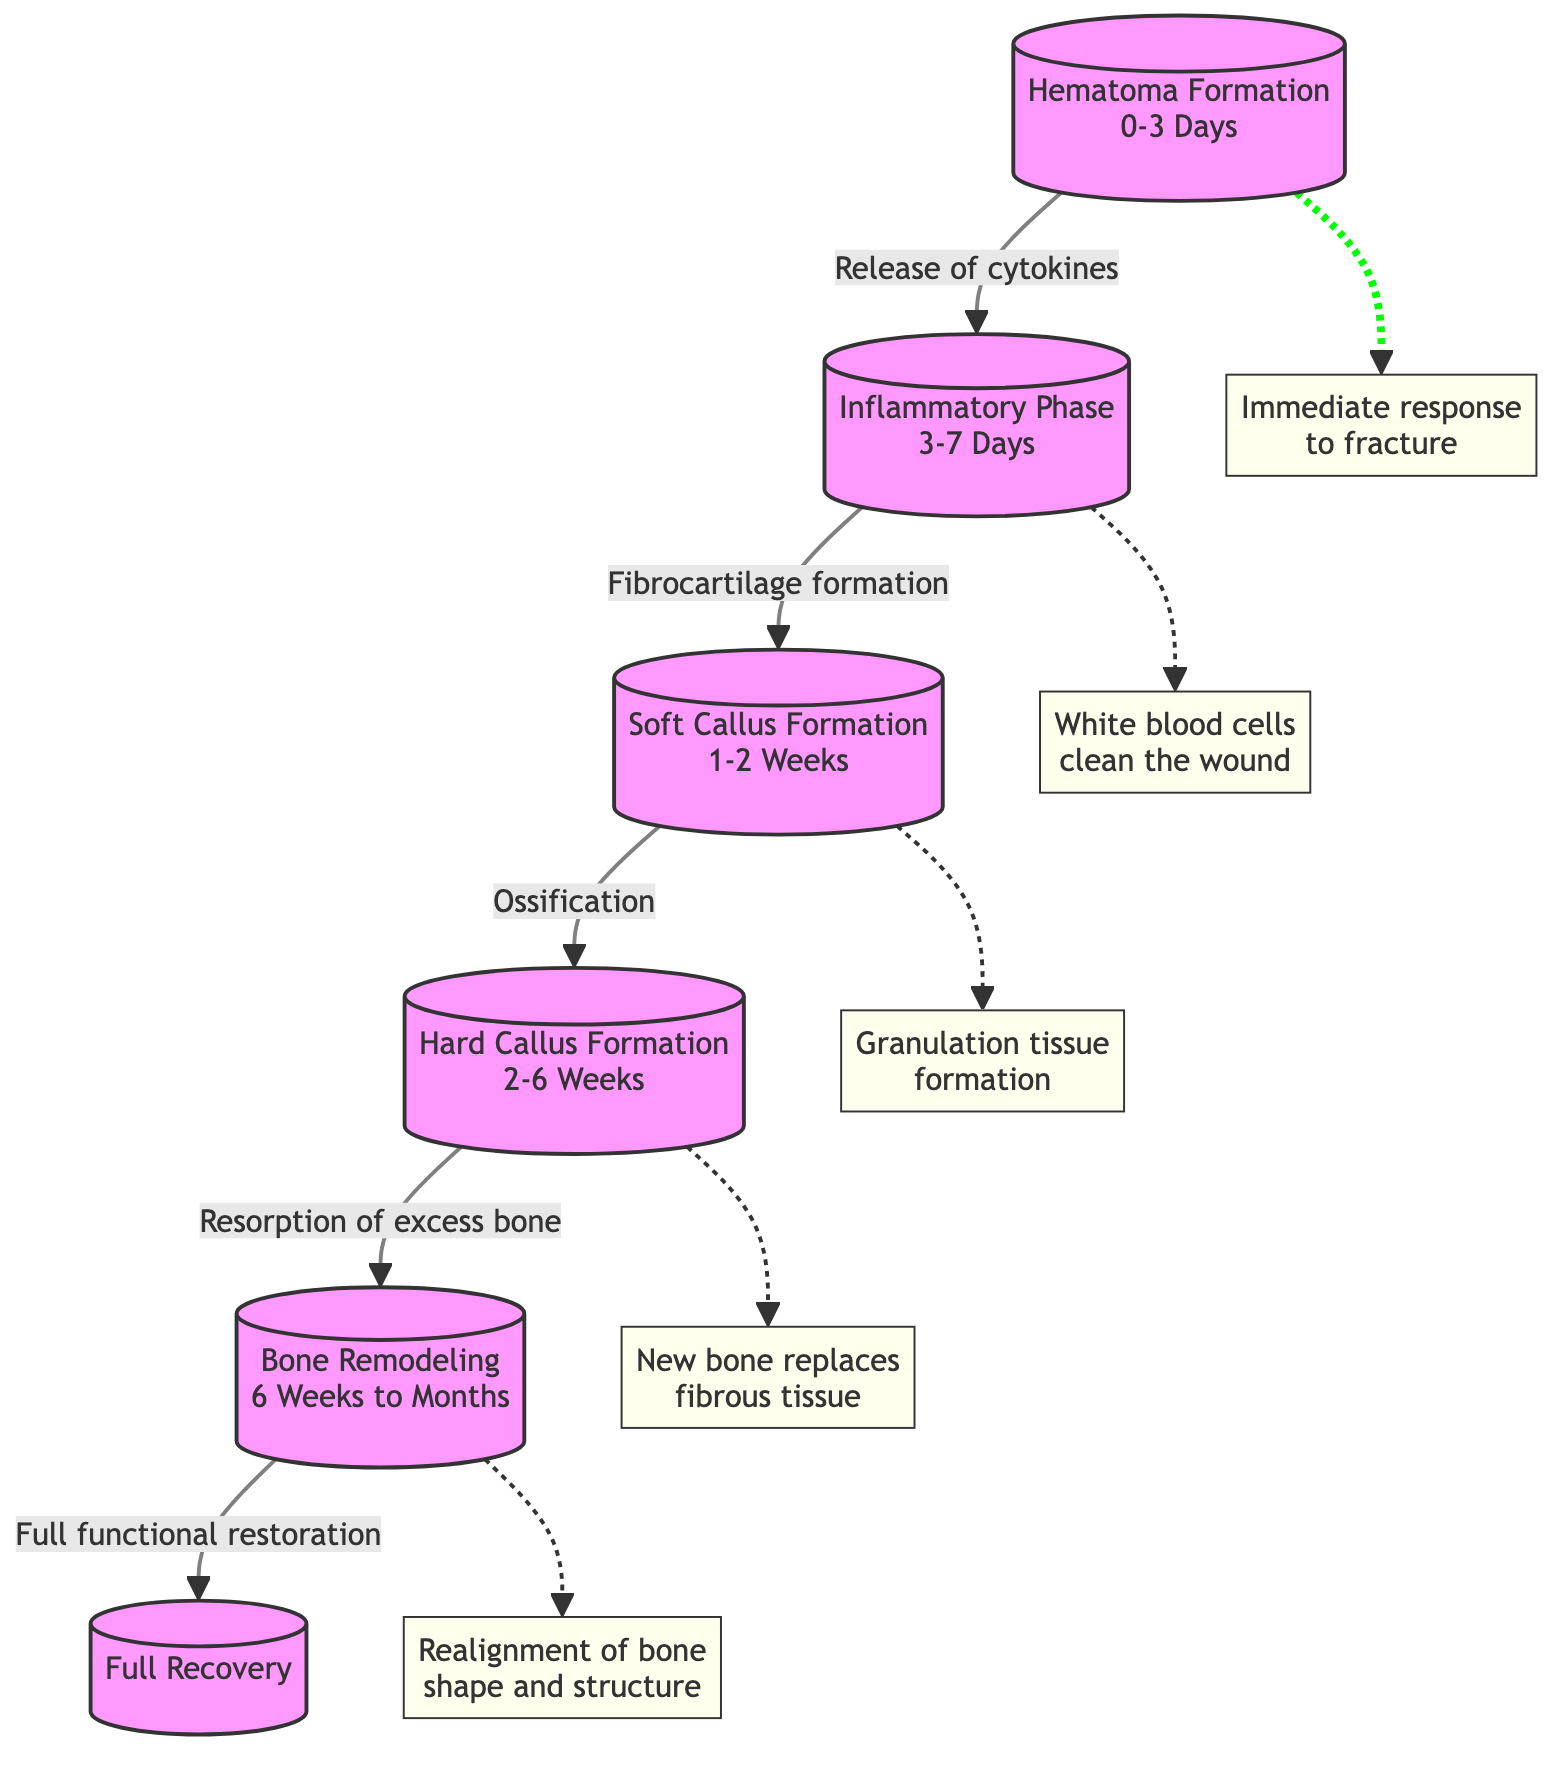What is the duration of the Hematoma Formation phase? The Hematoma Formation phase is indicated in the diagram to last from 0 to 3 days.
Answer: 0-3 Days What physiological process follows the Inflammatory Phase? The transition from the Inflammatory Phase is shown to be followed by Soft Callus Formation, indicated by the arrow connection with the label 'Fibrocartilage formation.'
Answer: Soft Callus Formation What comes after Hard Callus Formation? According to the diagram, Hard Callus Formation leads into the Bone Remodeling phase, shown by the arrow and the label 'Resorption of excess bone.'
Answer: Bone Remodeling How many total phases are displayed in the diagram? Counting each of the phases listed in the diagram yields a total of 6 distinct phases.
Answer: 6 What is the main physiological change associated with Soft Callus Formation? The diagram indicates that the main physiological change during Soft Callus Formation is 'Ossification,' as labeled on the connecting arrow leading to Hard Callus Formation.
Answer: Ossification What is the relationship between Bone Remodeling and Full Recovery? The diagram illustrates that Bone Remodeling is directly related to Full Recovery, with an arrow indicating that Bone Remodeling leads to 'Full functional restoration.'
Answer: Full functional restoration What happens during the Inflammatory Phase? During the Inflammatory Phase, the diagram notes that 'White blood cells clean the wound.' This is indicated as a side note connected to the Inflammatory Phase.
Answer: White blood cells clean the wound Which phase occurs between Soft Callus Formation and Bone Remodeling? The diagram shows that Hard Callus Formation occurs in-between Soft Callus Formation and Bone Remodeling, linked by the transitional labels.
Answer: Hard Callus Formation What title is given to the first phase in the diagram? The first phase is clearly labeled as 'Hematoma Formation,' chosen for its significant role at the start of the bone healing process.
Answer: Hematoma Formation 